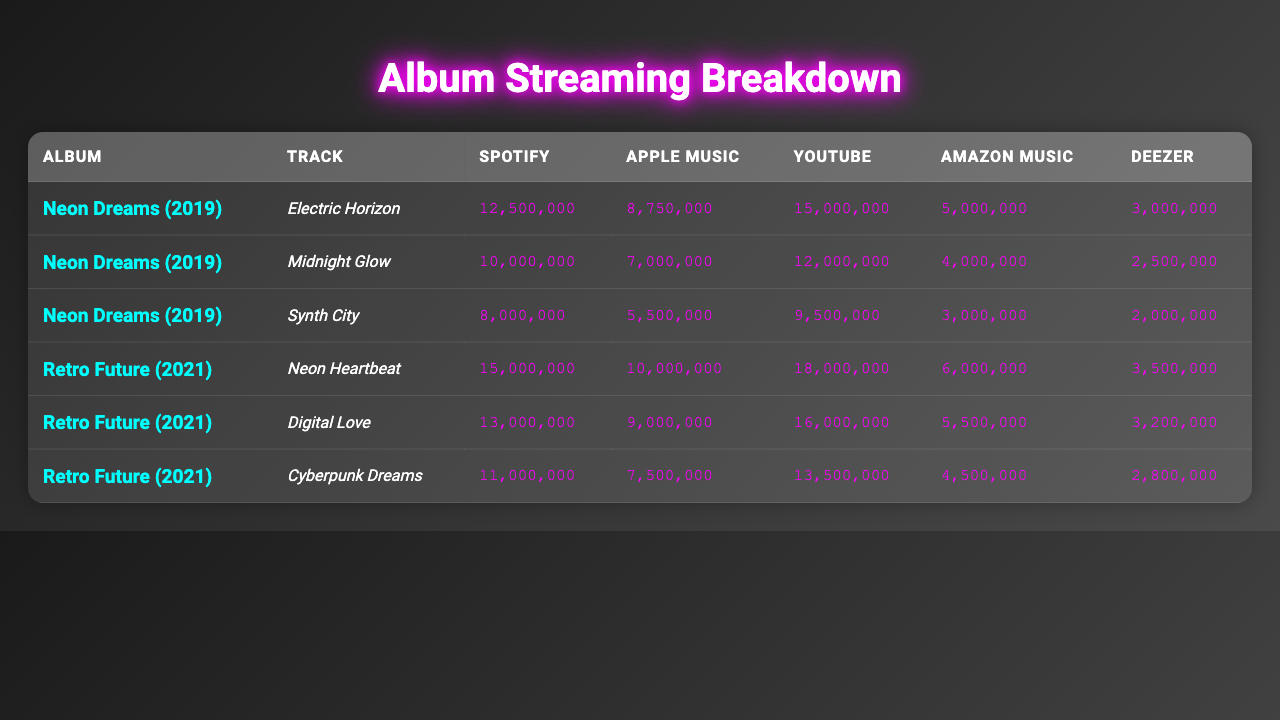What is the total number of Spotify streams for all tracks in the "Neon Dreams" album? The Spotify streams for "Neon Dreams" tracks are 12,500,000 for "Electric Horizon," 10,000,000 for "Midnight Glow," and 8,000,000 for "Synth City." Adding these together gives: 12,500,000 + 10,000,000 + 8,000,000 = 30,500,000.
Answer: 30,500,000 Which track from "Retro Future" has the highest number of YouTube views? The tracks from "Retro Future" have the following YouTube views: "Neon Heartbeat" has 18,000,000, "Digital Love" has 16,000,000, and "Cyberpunk Dreams" has 13,500,000. Comparing these, "Neon Heartbeat" has the highest views.
Answer: Neon Heartbeat Is the total number of streams on Amazon Music for "Digital Love" greater than the number of plays on Apple Music for "Midnight Glow"? "Digital Love" has 5,500,000 streams on Amazon Music, and "Midnight Glow" has 7,000,000 plays on Apple Music. Since 5,500,000 is less than 7,000,000, the statement is false.
Answer: No What is the average number of Deezer streams across all tracks in the "Neon Dreams" album? The Deezer streams for the tracks in "Neon Dreams" are 3,000,000 for "Electric Horizon," 2,500,000 for "Midnight Glow," and 2,000,000 for "Synth City." To find the average: (3,000,000 + 2,500,000 + 2,000,000) / 3 = 7,500,000 / 3 = 2,500,000.
Answer: 2,500,000 Which album has a total of 51 million plays across all streaming services? The "Neon Dreams" album has the following totals: Spotify (12,500,000) + Apple Music (8,750,000) + YouTube (15,000,000) + Amazon Music (5,000,000) + Deezer (3,000,000) = 44,250,000. The "Retro Future" album has: Spotify (15,000,000) + Apple Music (10,000,000) + YouTube (18,000,000) + Amazon Music (6,000,000) + Deezer (3,500,000) = 52,500,000. Therefore, neither album totals 51 million.
Answer: No What is the difference in Spotify streams between the track "Neon Heartbeat" from "Retro Future" and "Electric Horizon" from "Neon Dreams"? "Neon Heartbeat" has 15,000,000 Spotify streams and "Electric Horizon" has 12,500,000. The difference is 15,000,000 - 12,500,000 = 2,500,000.
Answer: 2,500,000 Which track has the second highest number of Apple Music plays? The Apple Music plays for the tracks are: "Neon Heartbeat" with 10,000,000, "Digital Love" with 9,000,000, "Midnight Glow" with 7,000,000, "Cyberpunk Dreams" with 7,500,000, and "Electric Horizon" with 8,750,000. The second highest is "Digital Love" with 9,000,000 plays.
Answer: Digital Love Are there any tracks from "Retro Future" that have more than 10 million streams on Spotify? The tracks from "Retro Future" have the following Spotify streams: "Neon Heartbeat" with 15,000,000, "Digital Love" with 13,000,000, and "Cyberpunk Dreams" with 11,000,000. All three tracks have more than 10 million Spotify streams.
Answer: Yes 